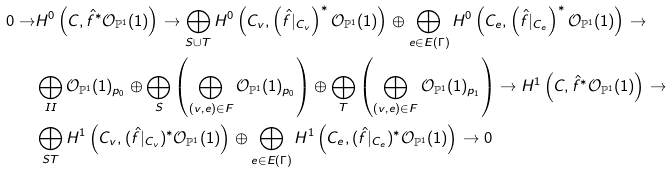<formula> <loc_0><loc_0><loc_500><loc_500>0 \rightarrow & H ^ { 0 } \left ( C , \hat { f } ^ { * } \mathcal { O } _ { \mathbb { P } ^ { 1 } } ( 1 ) \right ) \rightarrow \bigoplus _ { S \cup T } H ^ { 0 } \left ( C _ { v } , \left ( \hat { f } | _ { C _ { v } } \right ) ^ { * } \mathcal { O } _ { \mathbb { P } ^ { 1 } } ( 1 ) \right ) \oplus \bigoplus _ { e \in E ( \Gamma ) } H ^ { 0 } \left ( C _ { e } , \left ( \hat { f } | _ { C _ { e } } \right ) ^ { * } \mathcal { O } _ { \mathbb { P } ^ { 1 } } ( 1 ) \right ) \rightarrow \\ & \bigoplus _ { I I } \mathcal { O } _ { \mathbb { P } ^ { 1 } } ( 1 ) _ { p _ { 0 } } \oplus \bigoplus _ { S } \left ( \bigoplus _ { ( v , e ) \in F } \mathcal { O } _ { \mathbb { P } ^ { 1 } } ( 1 ) _ { p _ { 0 } } \right ) \oplus \bigoplus _ { T } \left ( \bigoplus _ { ( v , e ) \in F } \mathcal { O } _ { \mathbb { P } ^ { 1 } } ( 1 ) _ { p _ { 1 } } \right ) \rightarrow H ^ { 1 } \left ( C , \hat { f } ^ { * } \mathcal { O } _ { \mathbb { P } ^ { 1 } } ( 1 ) \right ) \rightarrow \\ & \bigoplus _ { S T } H ^ { 1 } \left ( C _ { v } , ( \hat { f } | _ { C _ { v } } ) ^ { * } \mathcal { O } _ { \mathbb { P } ^ { 1 } } ( 1 ) \right ) \oplus \bigoplus _ { e \in E ( \Gamma ) } H ^ { 1 } \left ( C _ { e } , ( \hat { f } | _ { C _ { e } } ) ^ { * } \mathcal { O } _ { \mathbb { P } ^ { 1 } } ( 1 ) \right ) \rightarrow 0</formula> 